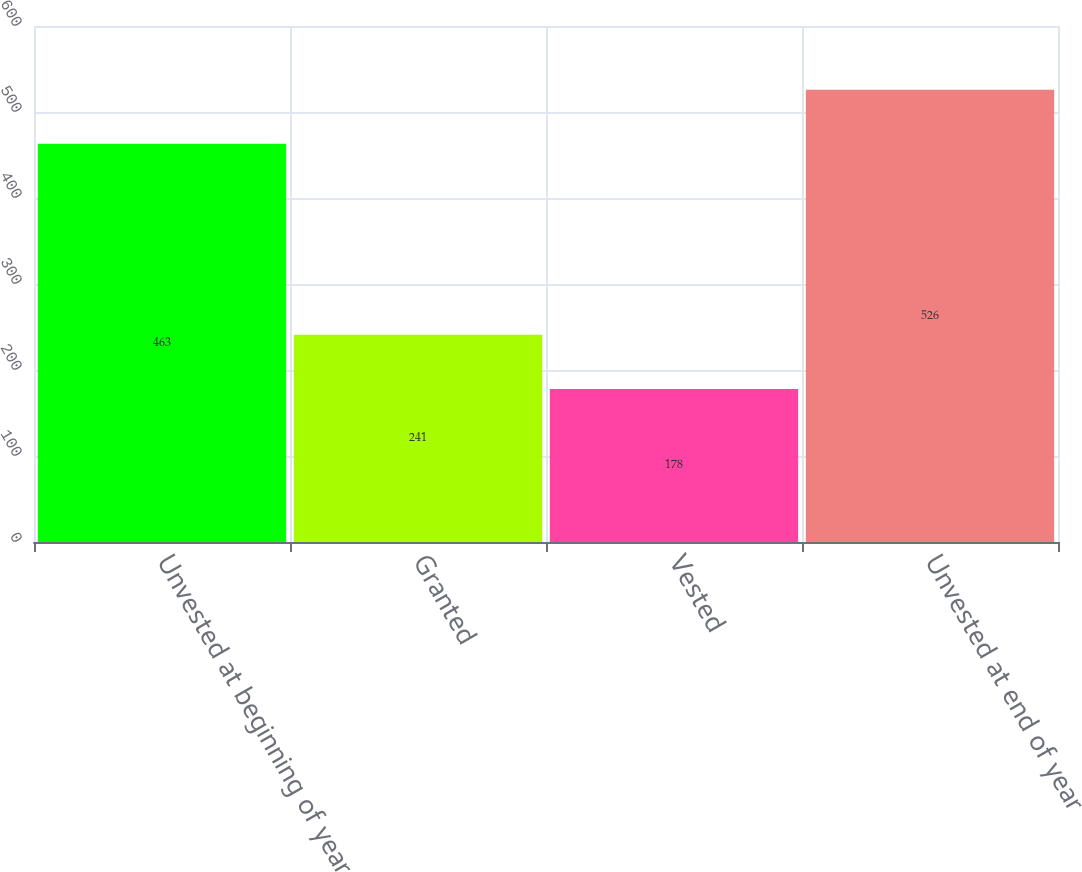<chart> <loc_0><loc_0><loc_500><loc_500><bar_chart><fcel>Unvested at beginning of year<fcel>Granted<fcel>Vested<fcel>Unvested at end of year<nl><fcel>463<fcel>241<fcel>178<fcel>526<nl></chart> 